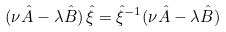<formula> <loc_0><loc_0><loc_500><loc_500>( \nu \hat { A } - \lambda \hat { B } ) \, \hat { \xi } = \hat { \xi } ^ { - 1 } ( \nu \hat { A } - \lambda \hat { B } )</formula> 